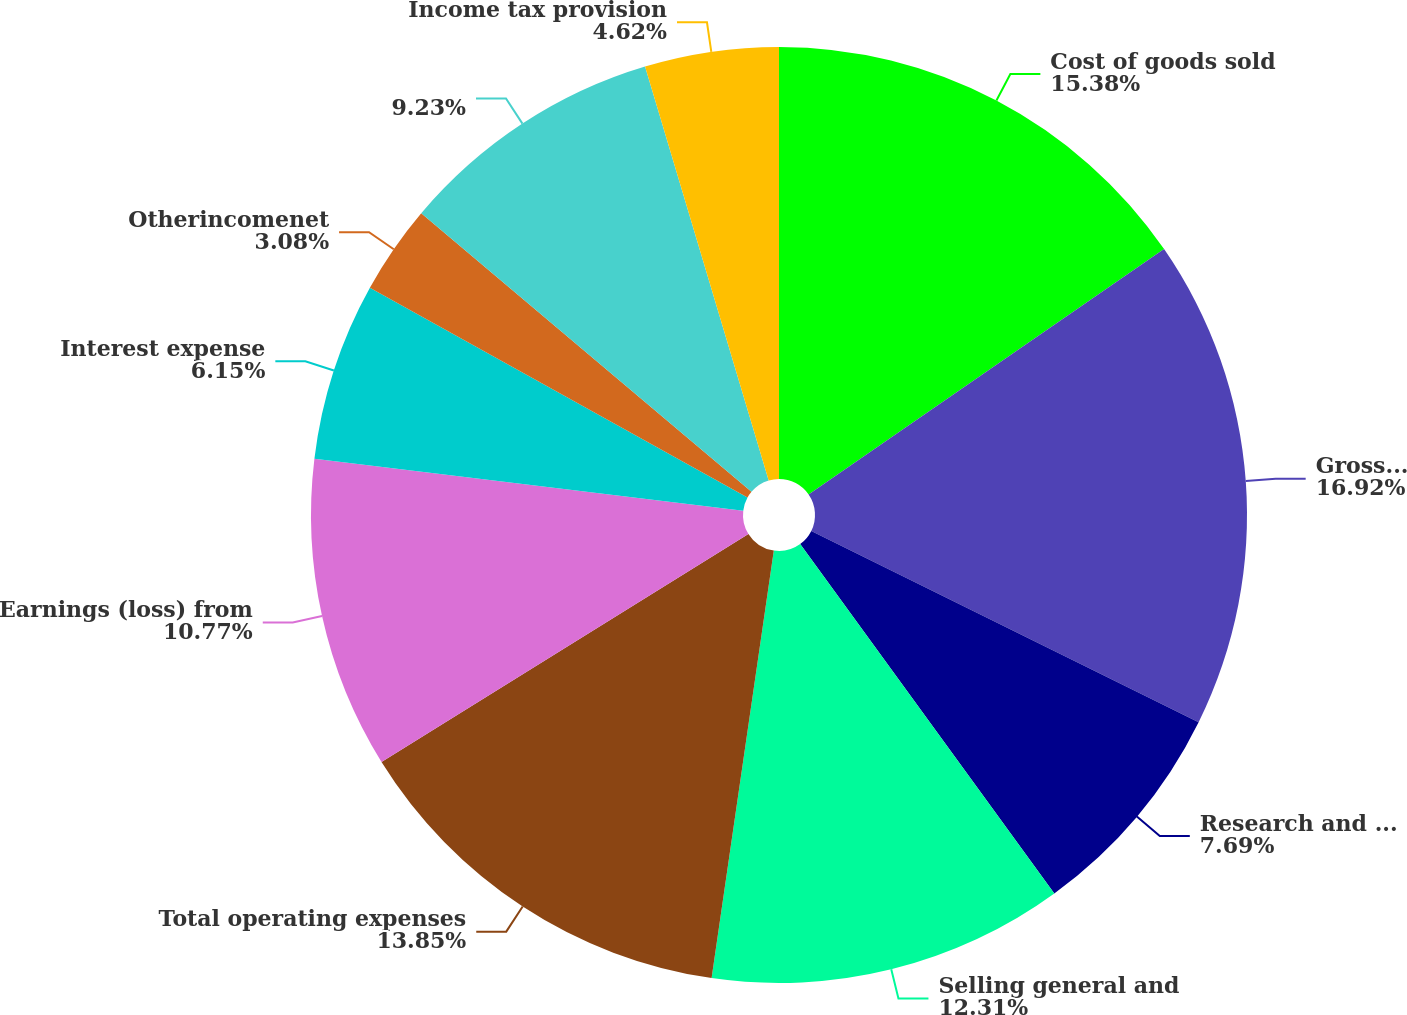<chart> <loc_0><loc_0><loc_500><loc_500><pie_chart><fcel>Cost of goods sold<fcel>Grossprofit<fcel>Research and development<fcel>Selling general and<fcel>Total operating expenses<fcel>Earnings (loss) from<fcel>Interest expense<fcel>Otherincomenet<fcel>Unnamed: 8<fcel>Income tax provision<nl><fcel>15.38%<fcel>16.92%<fcel>7.69%<fcel>12.31%<fcel>13.85%<fcel>10.77%<fcel>6.15%<fcel>3.08%<fcel>9.23%<fcel>4.62%<nl></chart> 